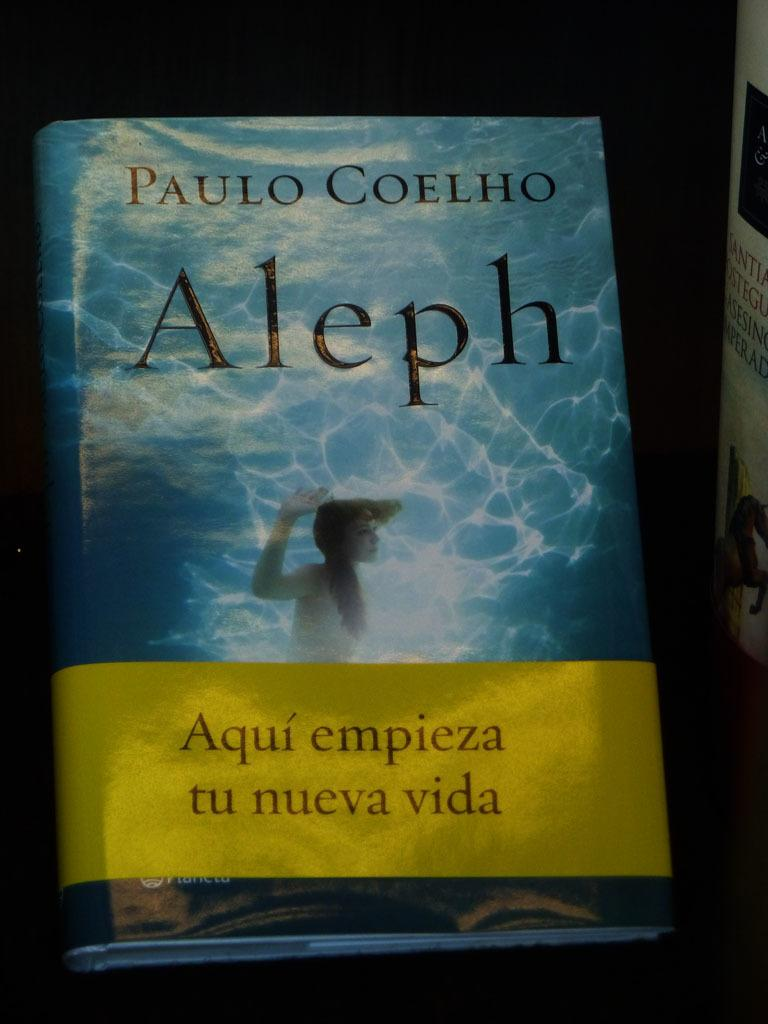<image>
Describe the image concisely. Aleph is a book written by the author Paulo Coelho. 